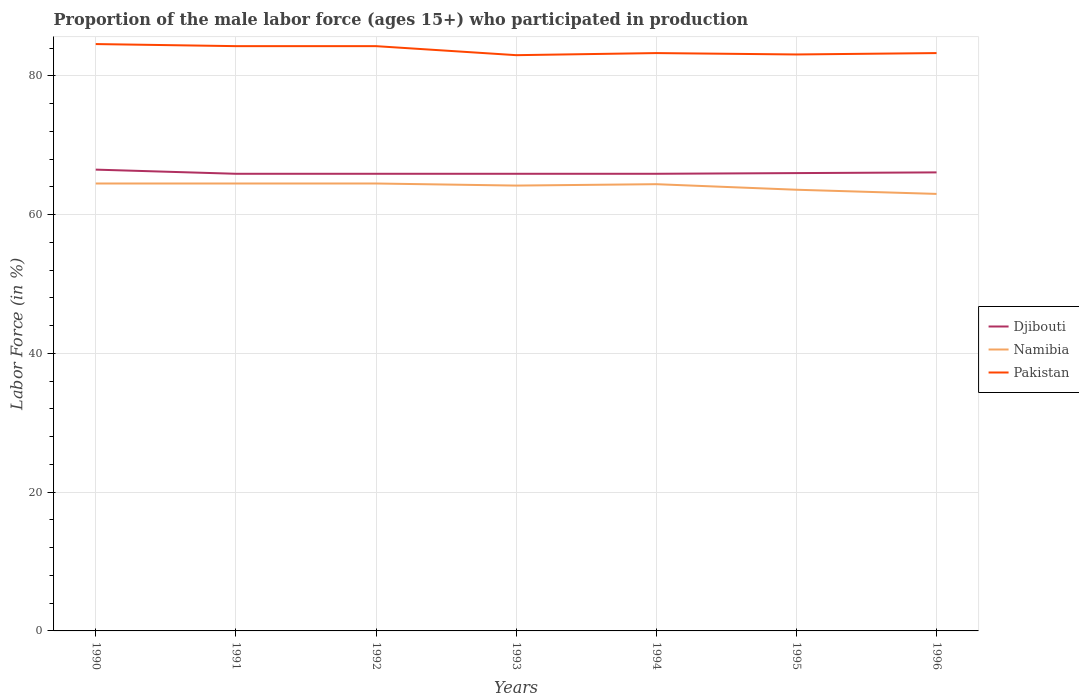How many different coloured lines are there?
Offer a very short reply. 3. Across all years, what is the maximum proportion of the male labor force who participated in production in Namibia?
Offer a very short reply. 63. What is the difference between the highest and the second highest proportion of the male labor force who participated in production in Pakistan?
Your answer should be compact. 1.6. Is the proportion of the male labor force who participated in production in Pakistan strictly greater than the proportion of the male labor force who participated in production in Djibouti over the years?
Your answer should be compact. No. How many lines are there?
Your response must be concise. 3. How many years are there in the graph?
Make the answer very short. 7. Are the values on the major ticks of Y-axis written in scientific E-notation?
Your answer should be compact. No. Does the graph contain grids?
Your answer should be very brief. Yes. Where does the legend appear in the graph?
Offer a very short reply. Center right. How are the legend labels stacked?
Give a very brief answer. Vertical. What is the title of the graph?
Your answer should be compact. Proportion of the male labor force (ages 15+) who participated in production. What is the label or title of the X-axis?
Your answer should be compact. Years. What is the label or title of the Y-axis?
Give a very brief answer. Labor Force (in %). What is the Labor Force (in %) of Djibouti in 1990?
Your answer should be very brief. 66.5. What is the Labor Force (in %) in Namibia in 1990?
Your answer should be very brief. 64.5. What is the Labor Force (in %) of Pakistan in 1990?
Your answer should be very brief. 84.6. What is the Labor Force (in %) in Djibouti in 1991?
Offer a terse response. 65.9. What is the Labor Force (in %) of Namibia in 1991?
Your answer should be very brief. 64.5. What is the Labor Force (in %) of Pakistan in 1991?
Provide a succinct answer. 84.3. What is the Labor Force (in %) of Djibouti in 1992?
Keep it short and to the point. 65.9. What is the Labor Force (in %) in Namibia in 1992?
Offer a terse response. 64.5. What is the Labor Force (in %) in Pakistan in 1992?
Offer a very short reply. 84.3. What is the Labor Force (in %) of Djibouti in 1993?
Make the answer very short. 65.9. What is the Labor Force (in %) of Namibia in 1993?
Provide a succinct answer. 64.2. What is the Labor Force (in %) in Djibouti in 1994?
Offer a terse response. 65.9. What is the Labor Force (in %) in Namibia in 1994?
Your answer should be compact. 64.4. What is the Labor Force (in %) of Pakistan in 1994?
Make the answer very short. 83.3. What is the Labor Force (in %) in Djibouti in 1995?
Offer a very short reply. 66. What is the Labor Force (in %) of Namibia in 1995?
Make the answer very short. 63.6. What is the Labor Force (in %) of Pakistan in 1995?
Provide a succinct answer. 83.1. What is the Labor Force (in %) of Djibouti in 1996?
Your response must be concise. 66.1. What is the Labor Force (in %) in Namibia in 1996?
Make the answer very short. 63. What is the Labor Force (in %) in Pakistan in 1996?
Make the answer very short. 83.3. Across all years, what is the maximum Labor Force (in %) in Djibouti?
Your response must be concise. 66.5. Across all years, what is the maximum Labor Force (in %) in Namibia?
Your answer should be compact. 64.5. Across all years, what is the maximum Labor Force (in %) of Pakistan?
Keep it short and to the point. 84.6. Across all years, what is the minimum Labor Force (in %) of Djibouti?
Make the answer very short. 65.9. Across all years, what is the minimum Labor Force (in %) in Namibia?
Keep it short and to the point. 63. What is the total Labor Force (in %) in Djibouti in the graph?
Your answer should be very brief. 462.2. What is the total Labor Force (in %) in Namibia in the graph?
Your response must be concise. 448.7. What is the total Labor Force (in %) of Pakistan in the graph?
Offer a very short reply. 585.9. What is the difference between the Labor Force (in %) of Djibouti in 1990 and that in 1992?
Give a very brief answer. 0.6. What is the difference between the Labor Force (in %) in Namibia in 1990 and that in 1992?
Your answer should be very brief. 0. What is the difference between the Labor Force (in %) in Pakistan in 1990 and that in 1993?
Offer a very short reply. 1.6. What is the difference between the Labor Force (in %) in Djibouti in 1990 and that in 1994?
Make the answer very short. 0.6. What is the difference between the Labor Force (in %) in Namibia in 1990 and that in 1994?
Provide a short and direct response. 0.1. What is the difference between the Labor Force (in %) of Pakistan in 1990 and that in 1995?
Make the answer very short. 1.5. What is the difference between the Labor Force (in %) in Namibia in 1990 and that in 1996?
Offer a very short reply. 1.5. What is the difference between the Labor Force (in %) of Pakistan in 1990 and that in 1996?
Give a very brief answer. 1.3. What is the difference between the Labor Force (in %) in Djibouti in 1991 and that in 1992?
Your answer should be very brief. 0. What is the difference between the Labor Force (in %) in Pakistan in 1991 and that in 1992?
Provide a short and direct response. 0. What is the difference between the Labor Force (in %) of Djibouti in 1991 and that in 1994?
Provide a short and direct response. 0. What is the difference between the Labor Force (in %) of Namibia in 1991 and that in 1994?
Offer a very short reply. 0.1. What is the difference between the Labor Force (in %) of Djibouti in 1991 and that in 1996?
Your answer should be compact. -0.2. What is the difference between the Labor Force (in %) in Pakistan in 1991 and that in 1996?
Provide a short and direct response. 1. What is the difference between the Labor Force (in %) in Namibia in 1992 and that in 1993?
Your answer should be very brief. 0.3. What is the difference between the Labor Force (in %) in Pakistan in 1992 and that in 1993?
Offer a very short reply. 1.3. What is the difference between the Labor Force (in %) in Pakistan in 1992 and that in 1995?
Provide a succinct answer. 1.2. What is the difference between the Labor Force (in %) of Namibia in 1993 and that in 1994?
Your answer should be very brief. -0.2. What is the difference between the Labor Force (in %) in Pakistan in 1993 and that in 1995?
Keep it short and to the point. -0.1. What is the difference between the Labor Force (in %) of Djibouti in 1993 and that in 1996?
Your answer should be compact. -0.2. What is the difference between the Labor Force (in %) in Namibia in 1993 and that in 1996?
Offer a very short reply. 1.2. What is the difference between the Labor Force (in %) in Djibouti in 1994 and that in 1995?
Ensure brevity in your answer.  -0.1. What is the difference between the Labor Force (in %) of Namibia in 1995 and that in 1996?
Give a very brief answer. 0.6. What is the difference between the Labor Force (in %) of Pakistan in 1995 and that in 1996?
Your answer should be compact. -0.2. What is the difference between the Labor Force (in %) of Djibouti in 1990 and the Labor Force (in %) of Namibia in 1991?
Provide a succinct answer. 2. What is the difference between the Labor Force (in %) of Djibouti in 1990 and the Labor Force (in %) of Pakistan in 1991?
Ensure brevity in your answer.  -17.8. What is the difference between the Labor Force (in %) in Namibia in 1990 and the Labor Force (in %) in Pakistan in 1991?
Offer a very short reply. -19.8. What is the difference between the Labor Force (in %) of Djibouti in 1990 and the Labor Force (in %) of Namibia in 1992?
Provide a short and direct response. 2. What is the difference between the Labor Force (in %) in Djibouti in 1990 and the Labor Force (in %) in Pakistan in 1992?
Keep it short and to the point. -17.8. What is the difference between the Labor Force (in %) of Namibia in 1990 and the Labor Force (in %) of Pakistan in 1992?
Your response must be concise. -19.8. What is the difference between the Labor Force (in %) of Djibouti in 1990 and the Labor Force (in %) of Namibia in 1993?
Provide a succinct answer. 2.3. What is the difference between the Labor Force (in %) of Djibouti in 1990 and the Labor Force (in %) of Pakistan in 1993?
Ensure brevity in your answer.  -16.5. What is the difference between the Labor Force (in %) in Namibia in 1990 and the Labor Force (in %) in Pakistan in 1993?
Provide a succinct answer. -18.5. What is the difference between the Labor Force (in %) of Djibouti in 1990 and the Labor Force (in %) of Pakistan in 1994?
Offer a very short reply. -16.8. What is the difference between the Labor Force (in %) of Namibia in 1990 and the Labor Force (in %) of Pakistan in 1994?
Your answer should be compact. -18.8. What is the difference between the Labor Force (in %) of Djibouti in 1990 and the Labor Force (in %) of Namibia in 1995?
Give a very brief answer. 2.9. What is the difference between the Labor Force (in %) in Djibouti in 1990 and the Labor Force (in %) in Pakistan in 1995?
Your answer should be compact. -16.6. What is the difference between the Labor Force (in %) in Namibia in 1990 and the Labor Force (in %) in Pakistan in 1995?
Make the answer very short. -18.6. What is the difference between the Labor Force (in %) of Djibouti in 1990 and the Labor Force (in %) of Pakistan in 1996?
Your answer should be compact. -16.8. What is the difference between the Labor Force (in %) in Namibia in 1990 and the Labor Force (in %) in Pakistan in 1996?
Your answer should be compact. -18.8. What is the difference between the Labor Force (in %) of Djibouti in 1991 and the Labor Force (in %) of Pakistan in 1992?
Offer a terse response. -18.4. What is the difference between the Labor Force (in %) in Namibia in 1991 and the Labor Force (in %) in Pakistan in 1992?
Provide a short and direct response. -19.8. What is the difference between the Labor Force (in %) in Djibouti in 1991 and the Labor Force (in %) in Namibia in 1993?
Offer a very short reply. 1.7. What is the difference between the Labor Force (in %) in Djibouti in 1991 and the Labor Force (in %) in Pakistan in 1993?
Your answer should be very brief. -17.1. What is the difference between the Labor Force (in %) in Namibia in 1991 and the Labor Force (in %) in Pakistan in 1993?
Your answer should be very brief. -18.5. What is the difference between the Labor Force (in %) of Djibouti in 1991 and the Labor Force (in %) of Pakistan in 1994?
Ensure brevity in your answer.  -17.4. What is the difference between the Labor Force (in %) in Namibia in 1991 and the Labor Force (in %) in Pakistan in 1994?
Provide a short and direct response. -18.8. What is the difference between the Labor Force (in %) of Djibouti in 1991 and the Labor Force (in %) of Pakistan in 1995?
Keep it short and to the point. -17.2. What is the difference between the Labor Force (in %) of Namibia in 1991 and the Labor Force (in %) of Pakistan in 1995?
Your response must be concise. -18.6. What is the difference between the Labor Force (in %) of Djibouti in 1991 and the Labor Force (in %) of Pakistan in 1996?
Make the answer very short. -17.4. What is the difference between the Labor Force (in %) of Namibia in 1991 and the Labor Force (in %) of Pakistan in 1996?
Your answer should be very brief. -18.8. What is the difference between the Labor Force (in %) of Djibouti in 1992 and the Labor Force (in %) of Namibia in 1993?
Make the answer very short. 1.7. What is the difference between the Labor Force (in %) of Djibouti in 1992 and the Labor Force (in %) of Pakistan in 1993?
Your answer should be compact. -17.1. What is the difference between the Labor Force (in %) of Namibia in 1992 and the Labor Force (in %) of Pakistan in 1993?
Keep it short and to the point. -18.5. What is the difference between the Labor Force (in %) in Djibouti in 1992 and the Labor Force (in %) in Pakistan in 1994?
Your response must be concise. -17.4. What is the difference between the Labor Force (in %) in Namibia in 1992 and the Labor Force (in %) in Pakistan in 1994?
Offer a very short reply. -18.8. What is the difference between the Labor Force (in %) of Djibouti in 1992 and the Labor Force (in %) of Pakistan in 1995?
Provide a succinct answer. -17.2. What is the difference between the Labor Force (in %) of Namibia in 1992 and the Labor Force (in %) of Pakistan in 1995?
Your answer should be very brief. -18.6. What is the difference between the Labor Force (in %) in Djibouti in 1992 and the Labor Force (in %) in Namibia in 1996?
Ensure brevity in your answer.  2.9. What is the difference between the Labor Force (in %) in Djibouti in 1992 and the Labor Force (in %) in Pakistan in 1996?
Offer a terse response. -17.4. What is the difference between the Labor Force (in %) in Namibia in 1992 and the Labor Force (in %) in Pakistan in 1996?
Provide a succinct answer. -18.8. What is the difference between the Labor Force (in %) of Djibouti in 1993 and the Labor Force (in %) of Namibia in 1994?
Ensure brevity in your answer.  1.5. What is the difference between the Labor Force (in %) of Djibouti in 1993 and the Labor Force (in %) of Pakistan in 1994?
Your answer should be compact. -17.4. What is the difference between the Labor Force (in %) in Namibia in 1993 and the Labor Force (in %) in Pakistan in 1994?
Your answer should be very brief. -19.1. What is the difference between the Labor Force (in %) in Djibouti in 1993 and the Labor Force (in %) in Pakistan in 1995?
Offer a terse response. -17.2. What is the difference between the Labor Force (in %) in Namibia in 1993 and the Labor Force (in %) in Pakistan in 1995?
Offer a terse response. -18.9. What is the difference between the Labor Force (in %) of Djibouti in 1993 and the Labor Force (in %) of Pakistan in 1996?
Offer a very short reply. -17.4. What is the difference between the Labor Force (in %) of Namibia in 1993 and the Labor Force (in %) of Pakistan in 1996?
Give a very brief answer. -19.1. What is the difference between the Labor Force (in %) in Djibouti in 1994 and the Labor Force (in %) in Namibia in 1995?
Provide a succinct answer. 2.3. What is the difference between the Labor Force (in %) of Djibouti in 1994 and the Labor Force (in %) of Pakistan in 1995?
Keep it short and to the point. -17.2. What is the difference between the Labor Force (in %) in Namibia in 1994 and the Labor Force (in %) in Pakistan in 1995?
Offer a terse response. -18.7. What is the difference between the Labor Force (in %) of Djibouti in 1994 and the Labor Force (in %) of Namibia in 1996?
Ensure brevity in your answer.  2.9. What is the difference between the Labor Force (in %) in Djibouti in 1994 and the Labor Force (in %) in Pakistan in 1996?
Your answer should be very brief. -17.4. What is the difference between the Labor Force (in %) of Namibia in 1994 and the Labor Force (in %) of Pakistan in 1996?
Make the answer very short. -18.9. What is the difference between the Labor Force (in %) of Djibouti in 1995 and the Labor Force (in %) of Pakistan in 1996?
Offer a terse response. -17.3. What is the difference between the Labor Force (in %) of Namibia in 1995 and the Labor Force (in %) of Pakistan in 1996?
Provide a succinct answer. -19.7. What is the average Labor Force (in %) of Djibouti per year?
Your response must be concise. 66.03. What is the average Labor Force (in %) in Namibia per year?
Provide a short and direct response. 64.1. What is the average Labor Force (in %) of Pakistan per year?
Ensure brevity in your answer.  83.7. In the year 1990, what is the difference between the Labor Force (in %) of Djibouti and Labor Force (in %) of Namibia?
Your response must be concise. 2. In the year 1990, what is the difference between the Labor Force (in %) in Djibouti and Labor Force (in %) in Pakistan?
Give a very brief answer. -18.1. In the year 1990, what is the difference between the Labor Force (in %) in Namibia and Labor Force (in %) in Pakistan?
Keep it short and to the point. -20.1. In the year 1991, what is the difference between the Labor Force (in %) in Djibouti and Labor Force (in %) in Pakistan?
Your answer should be very brief. -18.4. In the year 1991, what is the difference between the Labor Force (in %) of Namibia and Labor Force (in %) of Pakistan?
Provide a short and direct response. -19.8. In the year 1992, what is the difference between the Labor Force (in %) in Djibouti and Labor Force (in %) in Pakistan?
Your response must be concise. -18.4. In the year 1992, what is the difference between the Labor Force (in %) in Namibia and Labor Force (in %) in Pakistan?
Offer a very short reply. -19.8. In the year 1993, what is the difference between the Labor Force (in %) in Djibouti and Labor Force (in %) in Pakistan?
Your response must be concise. -17.1. In the year 1993, what is the difference between the Labor Force (in %) in Namibia and Labor Force (in %) in Pakistan?
Offer a terse response. -18.8. In the year 1994, what is the difference between the Labor Force (in %) in Djibouti and Labor Force (in %) in Pakistan?
Provide a succinct answer. -17.4. In the year 1994, what is the difference between the Labor Force (in %) of Namibia and Labor Force (in %) of Pakistan?
Your response must be concise. -18.9. In the year 1995, what is the difference between the Labor Force (in %) of Djibouti and Labor Force (in %) of Pakistan?
Offer a very short reply. -17.1. In the year 1995, what is the difference between the Labor Force (in %) in Namibia and Labor Force (in %) in Pakistan?
Provide a short and direct response. -19.5. In the year 1996, what is the difference between the Labor Force (in %) in Djibouti and Labor Force (in %) in Namibia?
Ensure brevity in your answer.  3.1. In the year 1996, what is the difference between the Labor Force (in %) of Djibouti and Labor Force (in %) of Pakistan?
Your answer should be compact. -17.2. In the year 1996, what is the difference between the Labor Force (in %) in Namibia and Labor Force (in %) in Pakistan?
Provide a succinct answer. -20.3. What is the ratio of the Labor Force (in %) of Djibouti in 1990 to that in 1991?
Your answer should be very brief. 1.01. What is the ratio of the Labor Force (in %) of Pakistan in 1990 to that in 1991?
Your answer should be very brief. 1. What is the ratio of the Labor Force (in %) in Djibouti in 1990 to that in 1992?
Ensure brevity in your answer.  1.01. What is the ratio of the Labor Force (in %) of Djibouti in 1990 to that in 1993?
Make the answer very short. 1.01. What is the ratio of the Labor Force (in %) in Namibia in 1990 to that in 1993?
Make the answer very short. 1. What is the ratio of the Labor Force (in %) in Pakistan in 1990 to that in 1993?
Make the answer very short. 1.02. What is the ratio of the Labor Force (in %) in Djibouti in 1990 to that in 1994?
Make the answer very short. 1.01. What is the ratio of the Labor Force (in %) of Namibia in 1990 to that in 1994?
Provide a short and direct response. 1. What is the ratio of the Labor Force (in %) of Pakistan in 1990 to that in 1994?
Make the answer very short. 1.02. What is the ratio of the Labor Force (in %) of Djibouti in 1990 to that in 1995?
Provide a succinct answer. 1.01. What is the ratio of the Labor Force (in %) of Namibia in 1990 to that in 1995?
Ensure brevity in your answer.  1.01. What is the ratio of the Labor Force (in %) in Pakistan in 1990 to that in 1995?
Make the answer very short. 1.02. What is the ratio of the Labor Force (in %) of Djibouti in 1990 to that in 1996?
Give a very brief answer. 1.01. What is the ratio of the Labor Force (in %) in Namibia in 1990 to that in 1996?
Offer a very short reply. 1.02. What is the ratio of the Labor Force (in %) of Pakistan in 1990 to that in 1996?
Make the answer very short. 1.02. What is the ratio of the Labor Force (in %) in Pakistan in 1991 to that in 1992?
Your response must be concise. 1. What is the ratio of the Labor Force (in %) of Djibouti in 1991 to that in 1993?
Keep it short and to the point. 1. What is the ratio of the Labor Force (in %) of Namibia in 1991 to that in 1993?
Your answer should be very brief. 1. What is the ratio of the Labor Force (in %) in Pakistan in 1991 to that in 1993?
Your response must be concise. 1.02. What is the ratio of the Labor Force (in %) of Djibouti in 1991 to that in 1994?
Your answer should be very brief. 1. What is the ratio of the Labor Force (in %) of Pakistan in 1991 to that in 1994?
Keep it short and to the point. 1.01. What is the ratio of the Labor Force (in %) of Djibouti in 1991 to that in 1995?
Offer a terse response. 1. What is the ratio of the Labor Force (in %) in Namibia in 1991 to that in 1995?
Your response must be concise. 1.01. What is the ratio of the Labor Force (in %) of Pakistan in 1991 to that in 1995?
Offer a very short reply. 1.01. What is the ratio of the Labor Force (in %) in Namibia in 1991 to that in 1996?
Make the answer very short. 1.02. What is the ratio of the Labor Force (in %) in Pakistan in 1991 to that in 1996?
Make the answer very short. 1.01. What is the ratio of the Labor Force (in %) in Djibouti in 1992 to that in 1993?
Your response must be concise. 1. What is the ratio of the Labor Force (in %) of Namibia in 1992 to that in 1993?
Keep it short and to the point. 1. What is the ratio of the Labor Force (in %) in Pakistan in 1992 to that in 1993?
Provide a succinct answer. 1.02. What is the ratio of the Labor Force (in %) in Namibia in 1992 to that in 1994?
Your answer should be very brief. 1. What is the ratio of the Labor Force (in %) in Namibia in 1992 to that in 1995?
Make the answer very short. 1.01. What is the ratio of the Labor Force (in %) in Pakistan in 1992 to that in 1995?
Keep it short and to the point. 1.01. What is the ratio of the Labor Force (in %) in Djibouti in 1992 to that in 1996?
Offer a very short reply. 1. What is the ratio of the Labor Force (in %) in Namibia in 1992 to that in 1996?
Give a very brief answer. 1.02. What is the ratio of the Labor Force (in %) of Pakistan in 1992 to that in 1996?
Ensure brevity in your answer.  1.01. What is the ratio of the Labor Force (in %) in Namibia in 1993 to that in 1994?
Your answer should be compact. 1. What is the ratio of the Labor Force (in %) of Pakistan in 1993 to that in 1994?
Give a very brief answer. 1. What is the ratio of the Labor Force (in %) of Namibia in 1993 to that in 1995?
Your response must be concise. 1.01. What is the ratio of the Labor Force (in %) of Namibia in 1993 to that in 1996?
Keep it short and to the point. 1.02. What is the ratio of the Labor Force (in %) in Pakistan in 1993 to that in 1996?
Keep it short and to the point. 1. What is the ratio of the Labor Force (in %) of Namibia in 1994 to that in 1995?
Ensure brevity in your answer.  1.01. What is the ratio of the Labor Force (in %) of Pakistan in 1994 to that in 1995?
Provide a short and direct response. 1. What is the ratio of the Labor Force (in %) in Namibia in 1994 to that in 1996?
Your answer should be compact. 1.02. What is the ratio of the Labor Force (in %) in Pakistan in 1994 to that in 1996?
Provide a short and direct response. 1. What is the ratio of the Labor Force (in %) in Djibouti in 1995 to that in 1996?
Your response must be concise. 1. What is the ratio of the Labor Force (in %) in Namibia in 1995 to that in 1996?
Your answer should be compact. 1.01. What is the difference between the highest and the second highest Labor Force (in %) in Djibouti?
Keep it short and to the point. 0.4. What is the difference between the highest and the second highest Labor Force (in %) in Namibia?
Ensure brevity in your answer.  0. What is the difference between the highest and the second highest Labor Force (in %) in Pakistan?
Ensure brevity in your answer.  0.3. What is the difference between the highest and the lowest Labor Force (in %) of Namibia?
Make the answer very short. 1.5. 